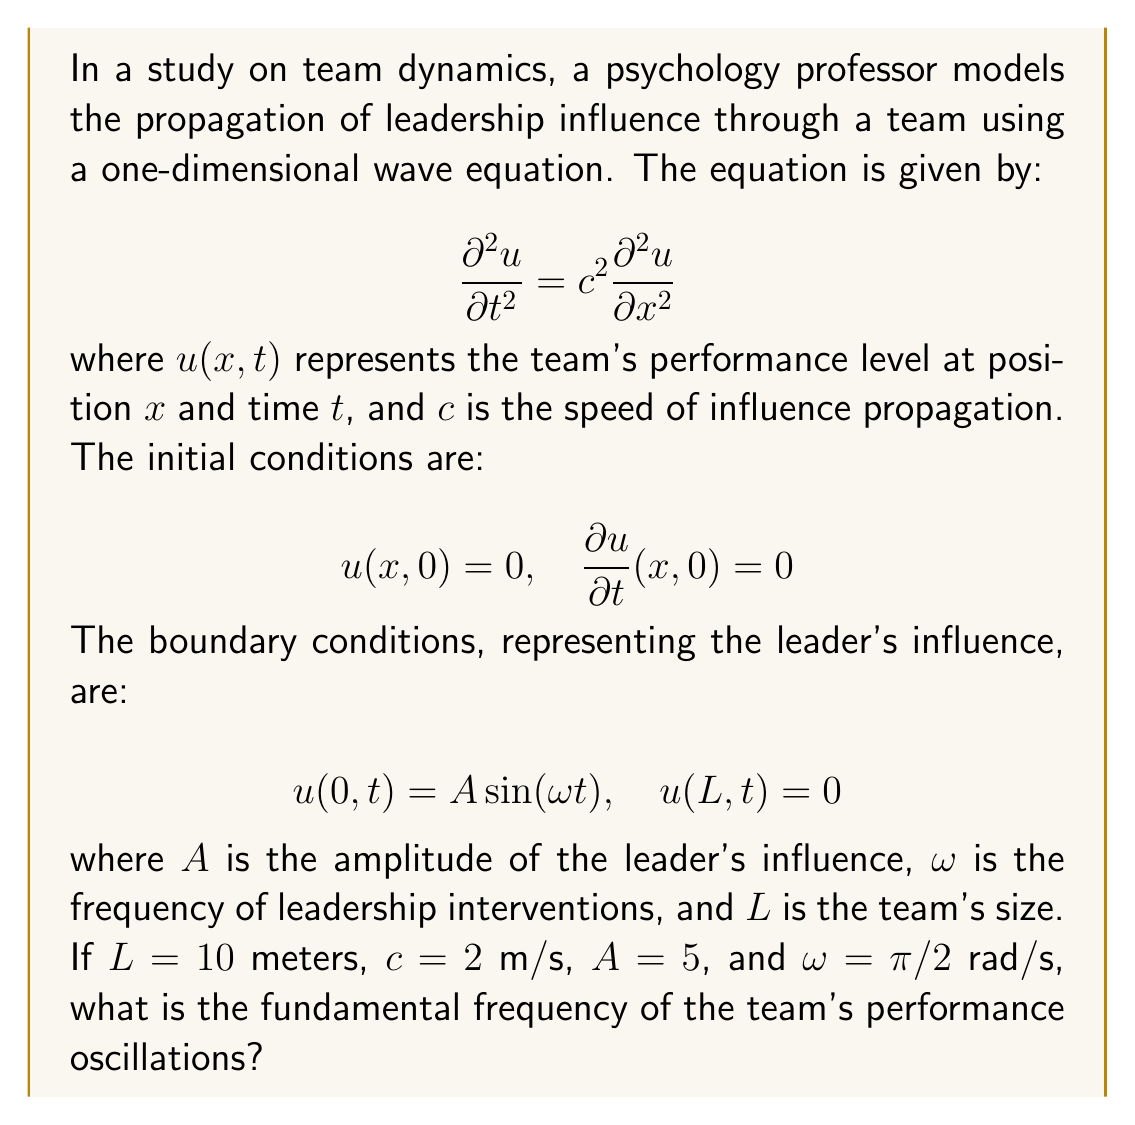Could you help me with this problem? To solve this problem, we need to follow these steps:

1) The general solution for the wave equation with the given boundary conditions is:

   $$u(x,t) = \sum_{n=1}^{\infty} B_n \sin(\frac{n\pi x}{L}) \sin(\frac{n\pi c t}{L})$$

2) The fundamental frequency corresponds to $n=1$ in this solution.

3) The angular frequency of the fundamental mode is:

   $$\omega_1 = \frac{\pi c}{L}$$

4) We are given:
   $L = 10$ m
   $c = 2$ m/s

5) Substituting these values:

   $$\omega_1 = \frac{\pi \cdot 2}{10} = \frac{\pi}{5}$$ rad/s

6) To convert from angular frequency to frequency in Hz, we use:

   $$f_1 = \frac{\omega_1}{2\pi} = \frac{\pi/5}{2\pi} = \frac{1}{10}$$ Hz

Therefore, the fundamental frequency of the team's performance oscillations is 0.1 Hz.
Answer: 0.1 Hz 